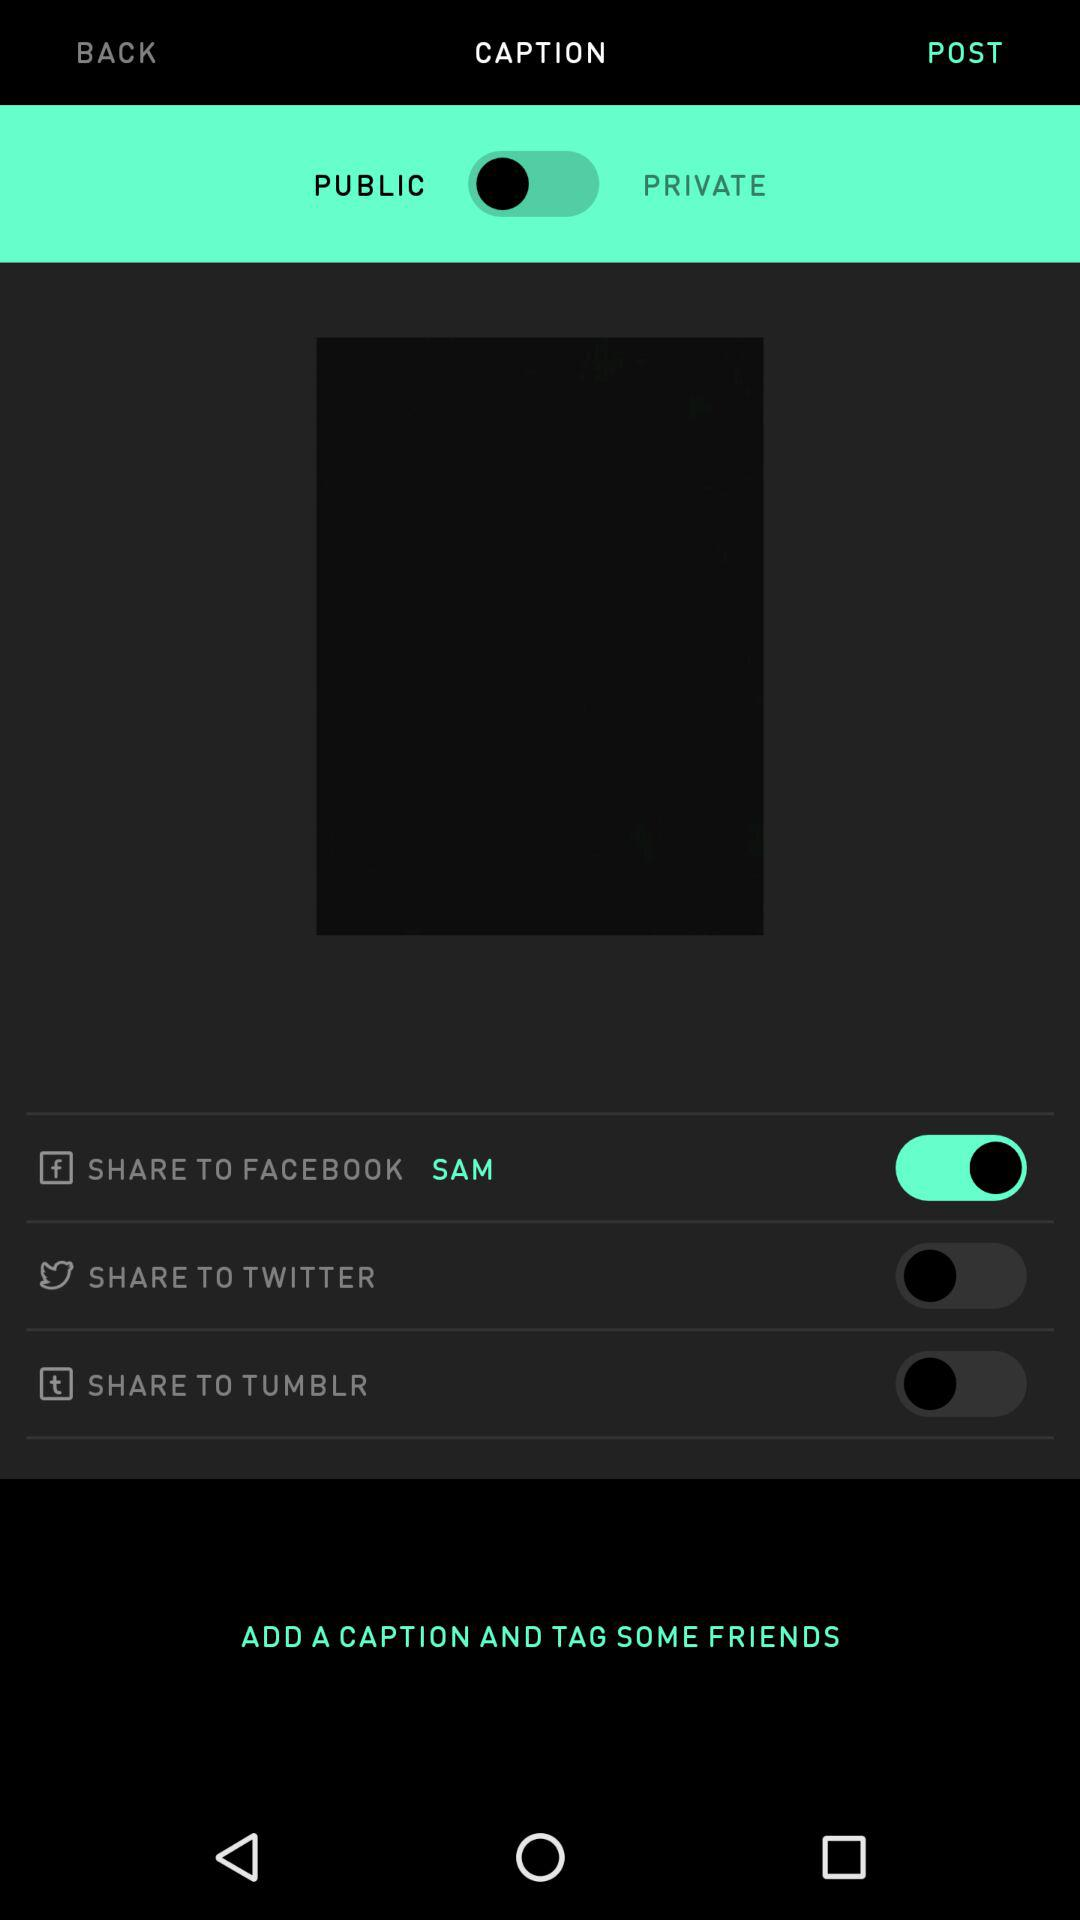What is the type of account? The type of account is public. 